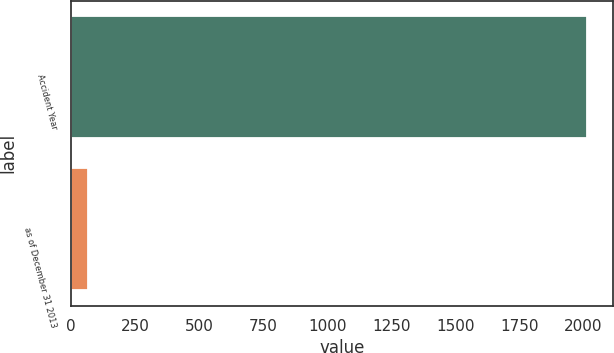Convert chart. <chart><loc_0><loc_0><loc_500><loc_500><bar_chart><fcel>Accident Year<fcel>as of December 31 2013<nl><fcel>2013<fcel>64<nl></chart> 